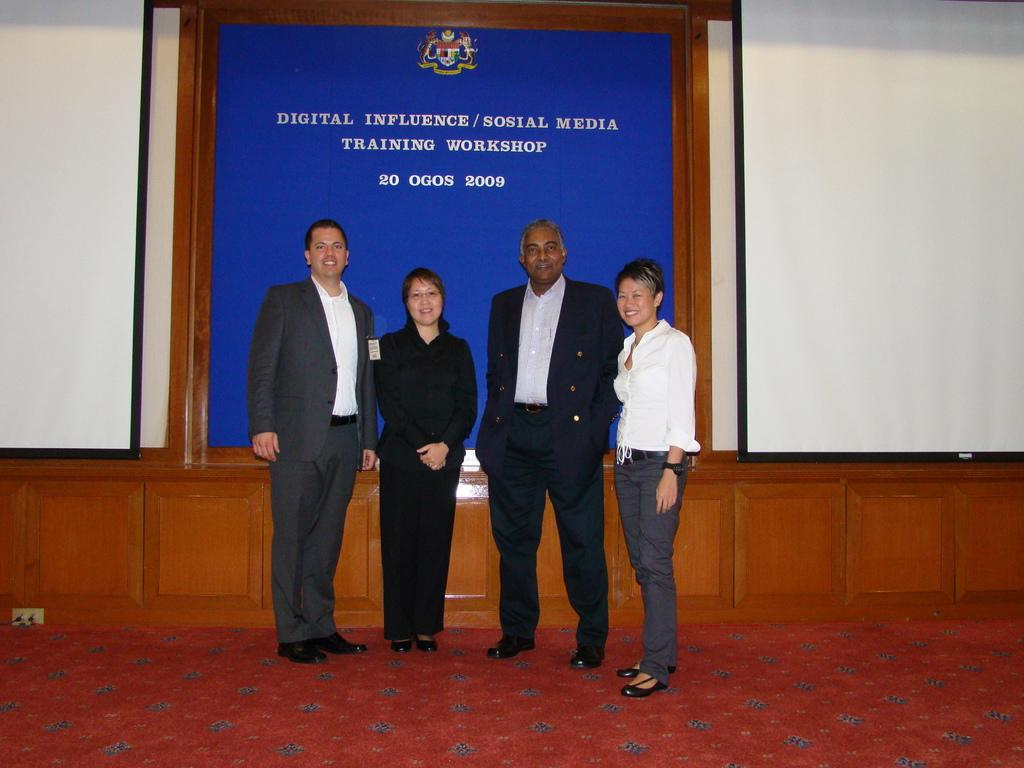How many people are present in the image? There are four persons standing in the image. Where are the persons standing? The persons are standing on a floor. What can be seen in the background of the image? There is a wall in the background of the image. What is on the wall? There is a board on the wall. What is written or displayed on the board? There is some text on the board. What type of spade is being used by one of the persons in the image? There is no spade present in the image; the persons are not using any tools or equipment. 